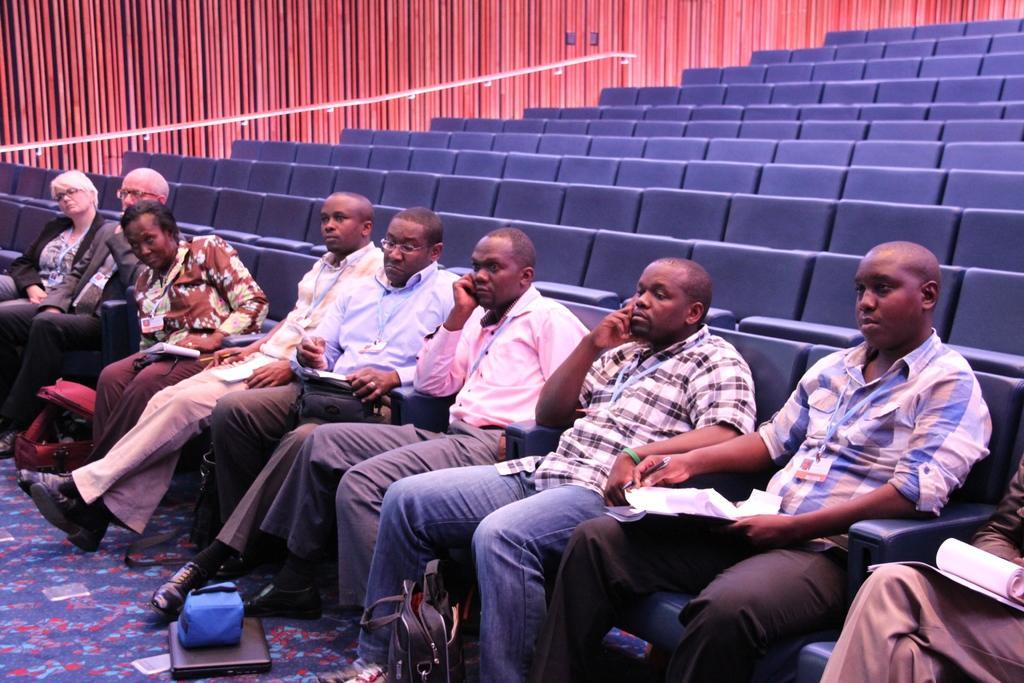How would you summarize this image in a sentence or two? In the picture I can see people sitting on chairs among them some are holding objects. In the background I can see chairs, bags and some other objects on the floor. 